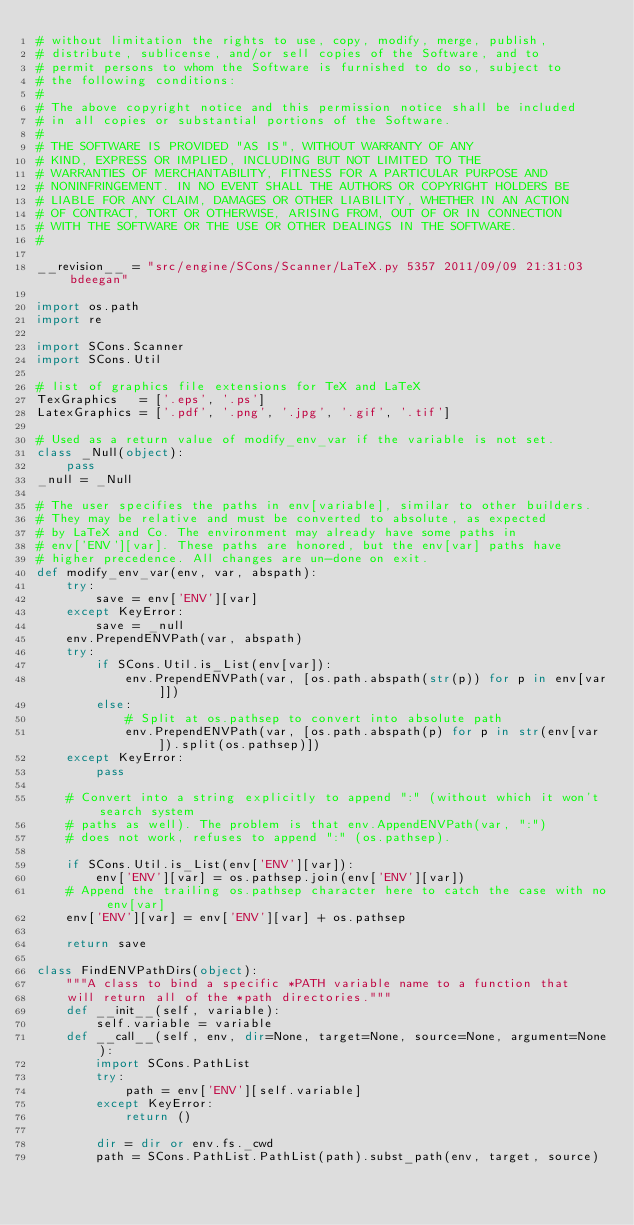Convert code to text. <code><loc_0><loc_0><loc_500><loc_500><_Python_># without limitation the rights to use, copy, modify, merge, publish,
# distribute, sublicense, and/or sell copies of the Software, and to
# permit persons to whom the Software is furnished to do so, subject to
# the following conditions:
#
# The above copyright notice and this permission notice shall be included
# in all copies or substantial portions of the Software.
#
# THE SOFTWARE IS PROVIDED "AS IS", WITHOUT WARRANTY OF ANY
# KIND, EXPRESS OR IMPLIED, INCLUDING BUT NOT LIMITED TO THE
# WARRANTIES OF MERCHANTABILITY, FITNESS FOR A PARTICULAR PURPOSE AND
# NONINFRINGEMENT. IN NO EVENT SHALL THE AUTHORS OR COPYRIGHT HOLDERS BE
# LIABLE FOR ANY CLAIM, DAMAGES OR OTHER LIABILITY, WHETHER IN AN ACTION
# OF CONTRACT, TORT OR OTHERWISE, ARISING FROM, OUT OF OR IN CONNECTION
# WITH THE SOFTWARE OR THE USE OR OTHER DEALINGS IN THE SOFTWARE.
#

__revision__ = "src/engine/SCons/Scanner/LaTeX.py 5357 2011/09/09 21:31:03 bdeegan"

import os.path
import re

import SCons.Scanner
import SCons.Util

# list of graphics file extensions for TeX and LaTeX
TexGraphics   = ['.eps', '.ps']
LatexGraphics = ['.pdf', '.png', '.jpg', '.gif', '.tif']

# Used as a return value of modify_env_var if the variable is not set.
class _Null(object):
    pass
_null = _Null

# The user specifies the paths in env[variable], similar to other builders.
# They may be relative and must be converted to absolute, as expected
# by LaTeX and Co. The environment may already have some paths in
# env['ENV'][var]. These paths are honored, but the env[var] paths have
# higher precedence. All changes are un-done on exit.
def modify_env_var(env, var, abspath):
    try:
        save = env['ENV'][var]
    except KeyError:
        save = _null
    env.PrependENVPath(var, abspath)
    try:
        if SCons.Util.is_List(env[var]):
            env.PrependENVPath(var, [os.path.abspath(str(p)) for p in env[var]])
        else:
            # Split at os.pathsep to convert into absolute path
            env.PrependENVPath(var, [os.path.abspath(p) for p in str(env[var]).split(os.pathsep)])
    except KeyError:
        pass

    # Convert into a string explicitly to append ":" (without which it won't search system
    # paths as well). The problem is that env.AppendENVPath(var, ":")
    # does not work, refuses to append ":" (os.pathsep).

    if SCons.Util.is_List(env['ENV'][var]):
        env['ENV'][var] = os.pathsep.join(env['ENV'][var])
    # Append the trailing os.pathsep character here to catch the case with no env[var]
    env['ENV'][var] = env['ENV'][var] + os.pathsep

    return save

class FindENVPathDirs(object):
    """A class to bind a specific *PATH variable name to a function that
    will return all of the *path directories."""
    def __init__(self, variable):
        self.variable = variable
    def __call__(self, env, dir=None, target=None, source=None, argument=None):
        import SCons.PathList
        try:
            path = env['ENV'][self.variable]
        except KeyError:
            return ()

        dir = dir or env.fs._cwd
        path = SCons.PathList.PathList(path).subst_path(env, target, source)</code> 